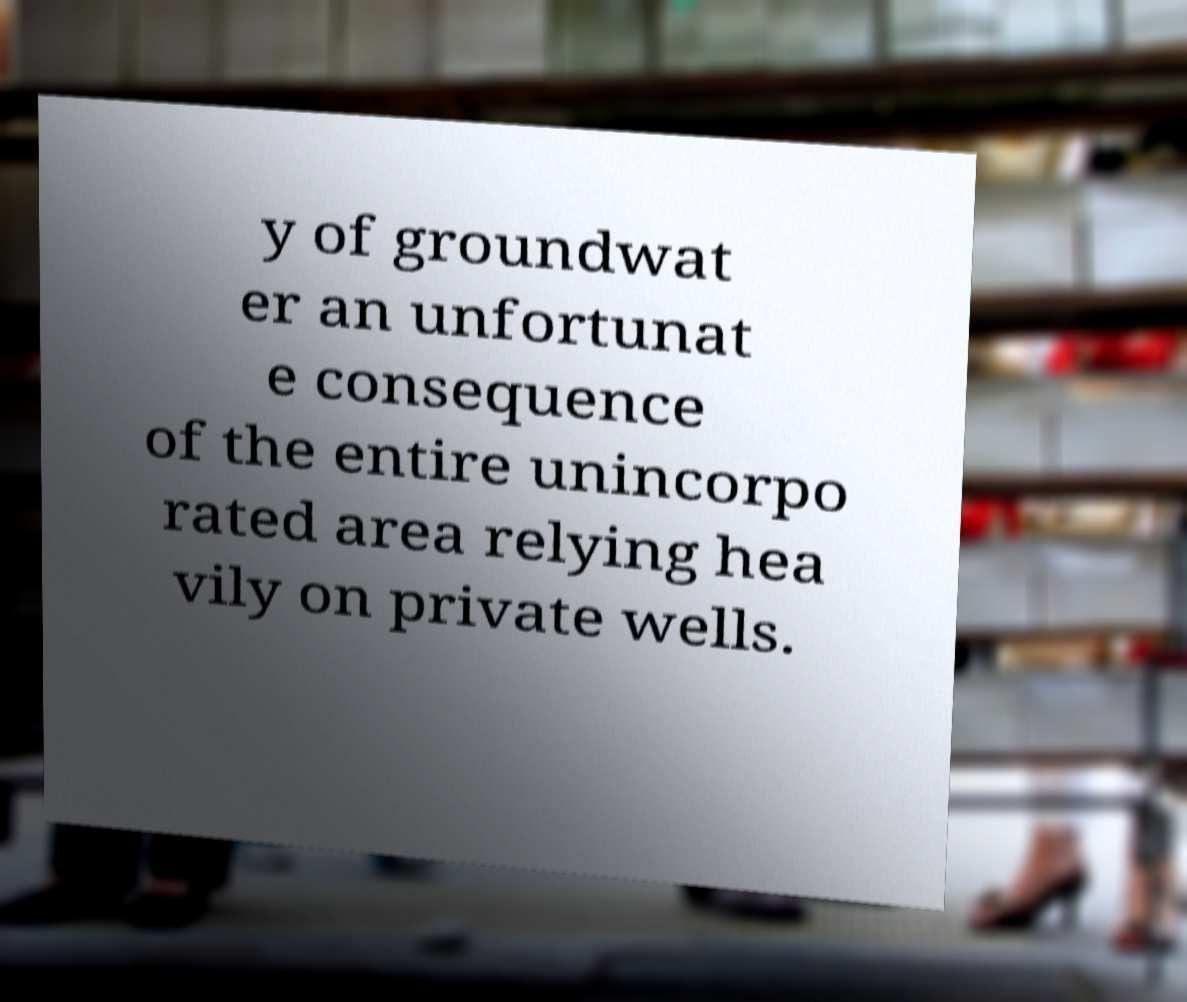Can you read and provide the text displayed in the image?This photo seems to have some interesting text. Can you extract and type it out for me? y of groundwat er an unfortunat e consequence of the entire unincorpo rated area relying hea vily on private wells. 